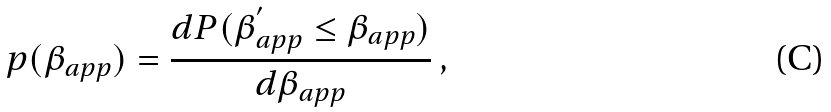<formula> <loc_0><loc_0><loc_500><loc_500>p ( \beta _ { a p p } ) = \frac { { d P ( \beta _ { a p p } ^ { ^ { \prime } } \leq \beta _ { a p p } ) } } { { d \beta _ { a p p } } } \, ,</formula> 